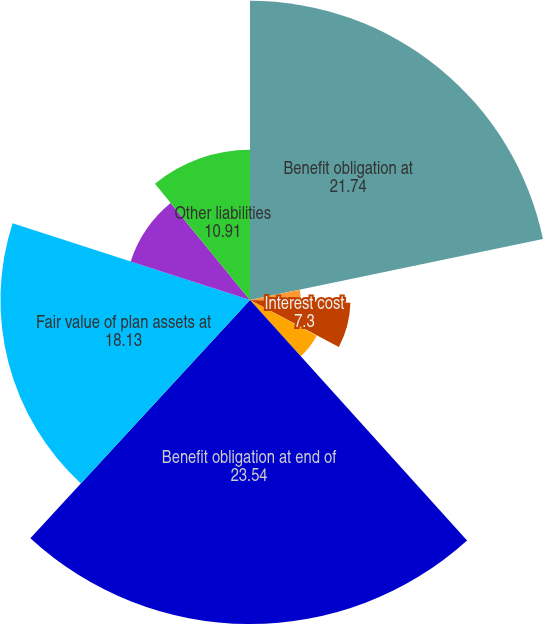Convert chart to OTSL. <chart><loc_0><loc_0><loc_500><loc_500><pie_chart><fcel>Benefit obligation at<fcel>Service cost<fcel>Interest cost<fcel>Actuarial loss<fcel>Benefits paid<fcel>Benefit obligation at end of<fcel>Fair value of plan assets at<fcel>Actual return on plan assets<fcel>Other liabilities<nl><fcel>21.74%<fcel>3.69%<fcel>7.3%<fcel>0.09%<fcel>5.5%<fcel>23.54%<fcel>18.13%<fcel>9.11%<fcel>10.91%<nl></chart> 